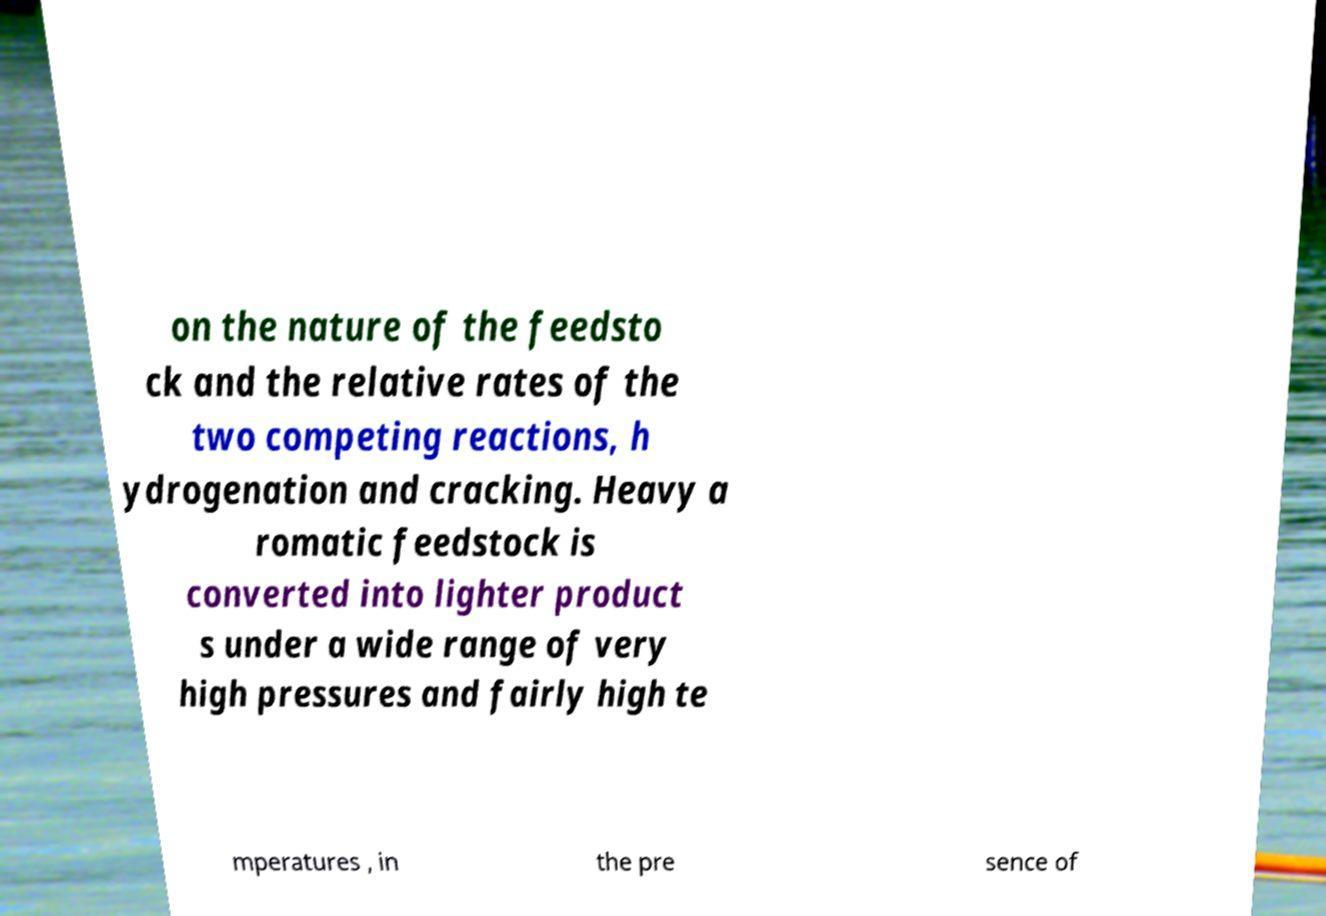Please identify and transcribe the text found in this image. on the nature of the feedsto ck and the relative rates of the two competing reactions, h ydrogenation and cracking. Heavy a romatic feedstock is converted into lighter product s under a wide range of very high pressures and fairly high te mperatures , in the pre sence of 